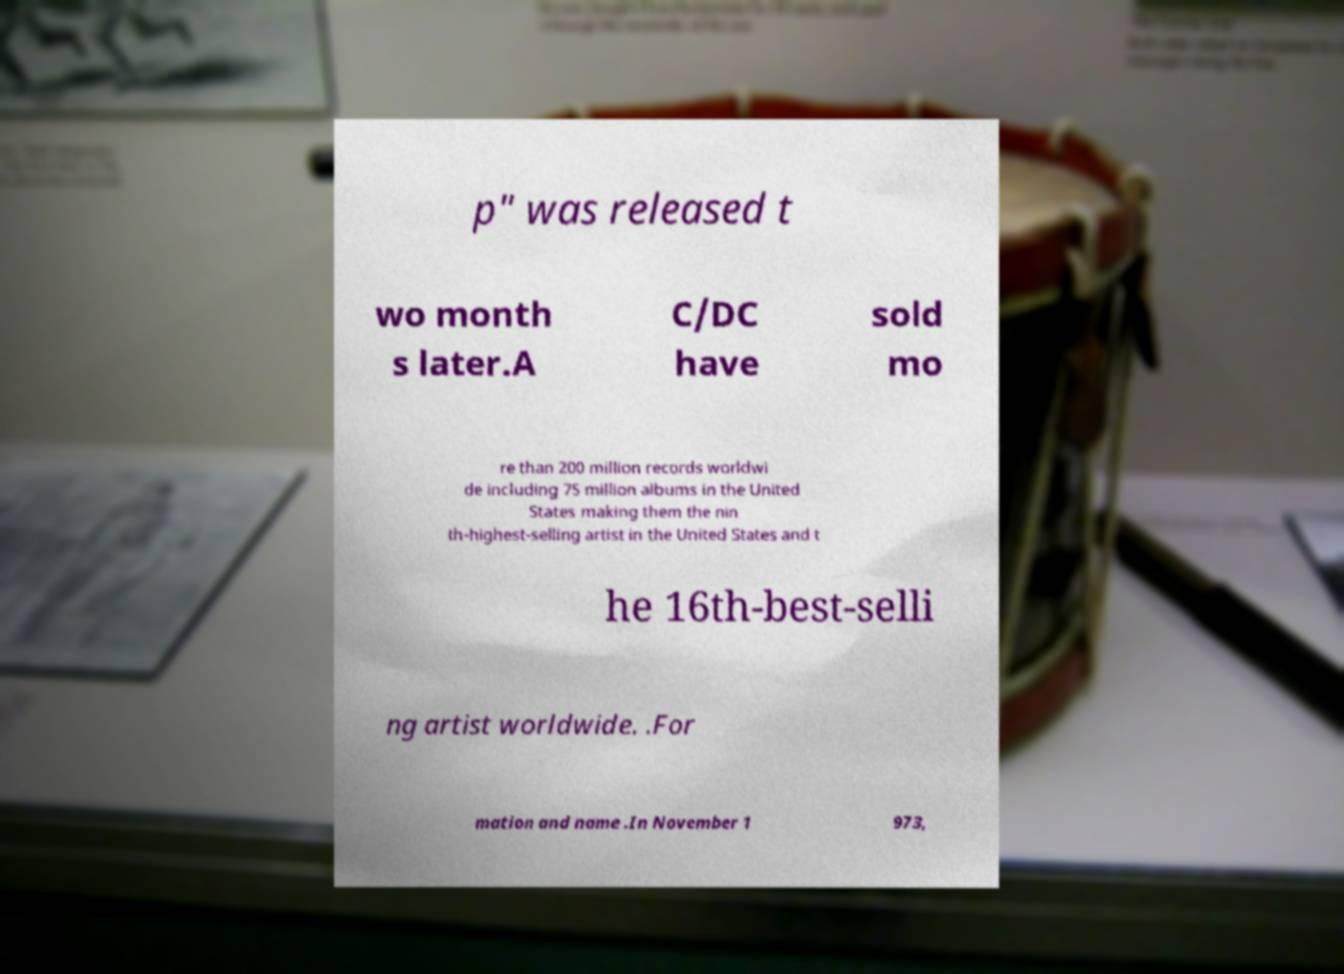Please read and relay the text visible in this image. What does it say? p" was released t wo month s later.A C/DC have sold mo re than 200 million records worldwi de including 75 million albums in the United States making them the nin th-highest-selling artist in the United States and t he 16th-best-selli ng artist worldwide. .For mation and name .In November 1 973, 